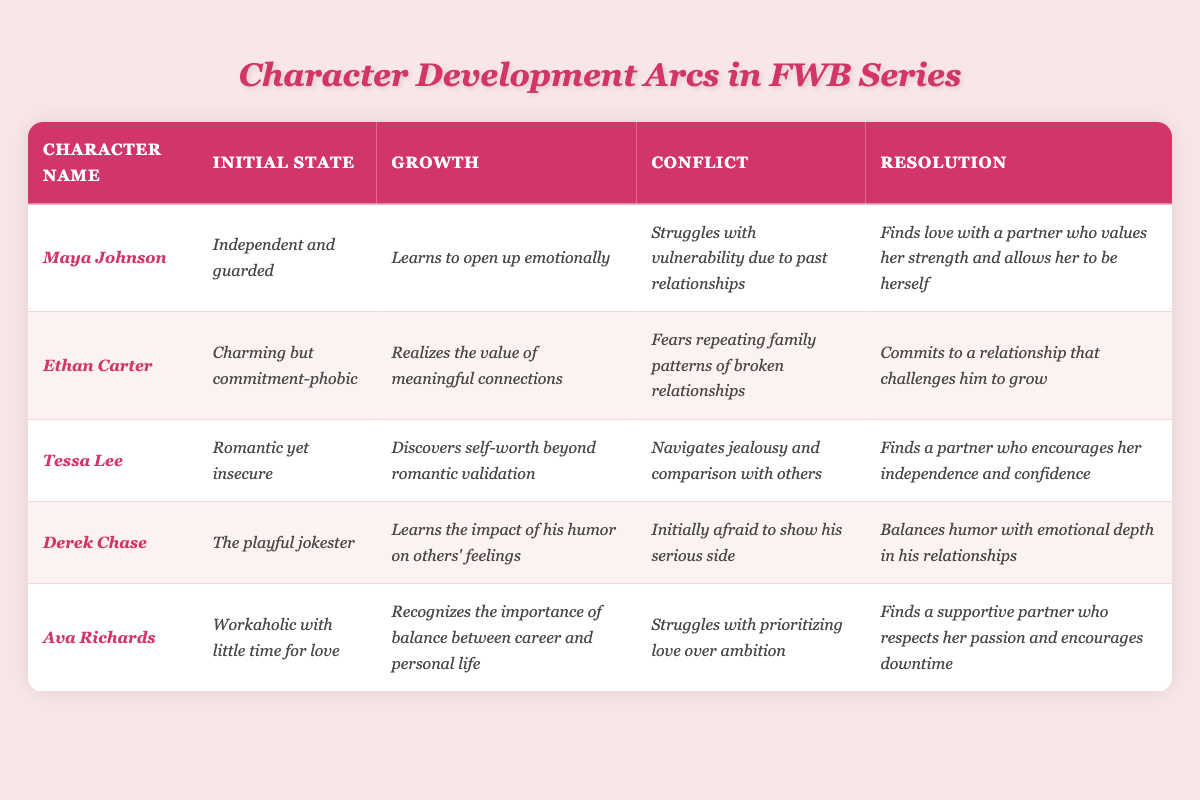What is the initial state of Maya Johnson? According to the table, Maya Johnson's initial state is described as "Independent and guarded."
Answer: Independent and guarded What character learns to open up emotionally? The table indicates that Maya Johnson is the character who learns to open up emotionally during her development arc.
Answer: Maya Johnson Which character struggles with jealousy? Tessa Lee is the character mentioned in the table who navigates jealousy and comparison with others as part of her conflict.
Answer: Tessa Lee Does Derek Chase start as serious or playful? The table clearly states that Derek Chase starts as "The playful jokester," indicating he is not serious at the beginning.
Answer: No Which character resolves to balance work and personal life? Ava Richards resolves to recognize the importance of balance between her career and personal life, as indicated in the resolution section of her development arc.
Answer: Ava Richards Which character's growth involves recognizing self-worth beyond romantic validation? The table specifies that Tessa Lee's growth involves discovering self-worth beyond romantic validation.
Answer: Tessa Lee How many characters in the table have a resolution related to finding a supportive partner? The table indicates that both Maya Johnson and Ava Richards find supportive partners in their resolutions, making it two characters.
Answer: 2 Which character has fears related to family patterns of broken relationships? According to the table, Ethan Carter has fears of repeating family patterns of broken relationships as part of his conflict.
Answer: Ethan Carter What is the resolution for Ethan Carter? The table states that Ethan Carter's resolution is to commit to a relationship that challenges him to grow.
Answer: Commits to a relationship that challenges him to grow Compare the initial states of Maya Johnson and Ethan Carter. How are they different? Maya Johnson's initial state is "Independent and guarded," whereas Ethan Carter's initial state is "Charming but commitment-phobic," showing that Maya is more self-reliant while Ethan struggles with commitment.
Answer: They differ in independence vs. commitment issues 